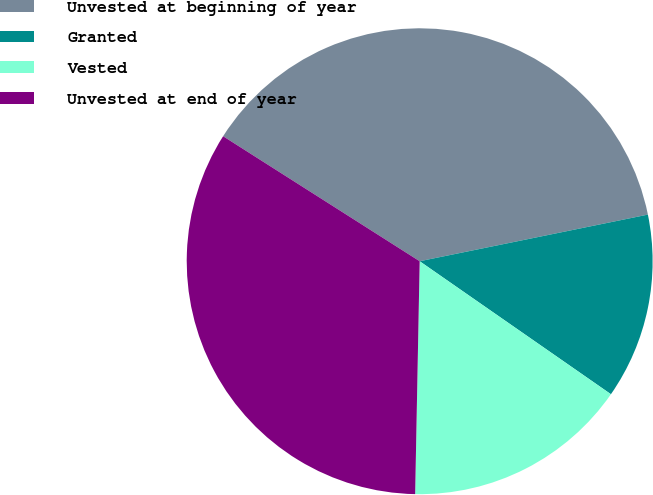Convert chart to OTSL. <chart><loc_0><loc_0><loc_500><loc_500><pie_chart><fcel>Unvested at beginning of year<fcel>Granted<fcel>Vested<fcel>Unvested at end of year<nl><fcel>37.78%<fcel>12.88%<fcel>15.64%<fcel>33.71%<nl></chart> 